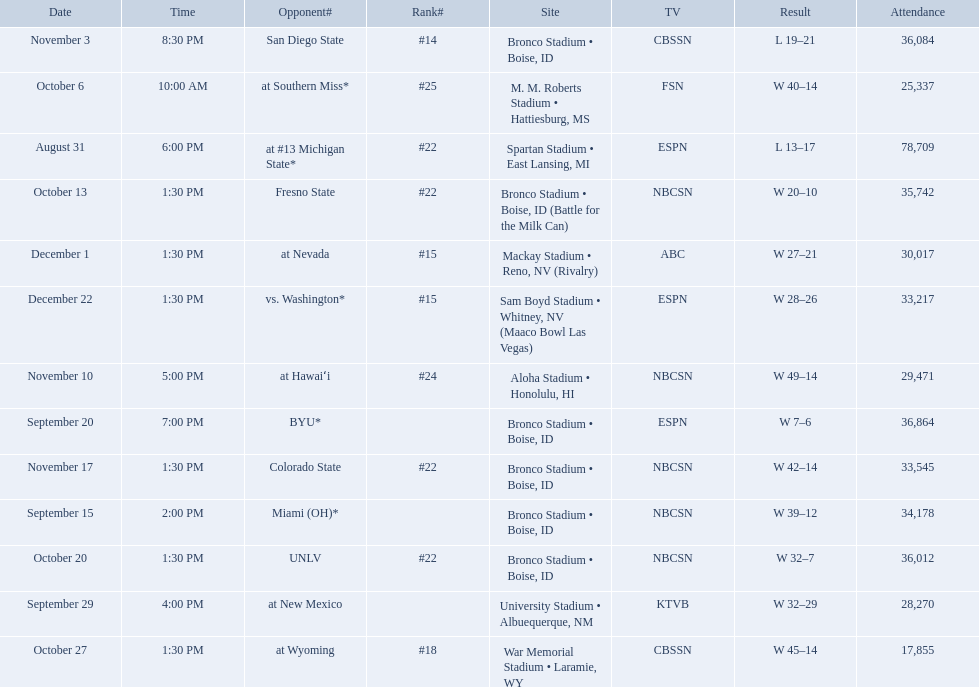What are all of the rankings? #22, , , , #25, #22, #22, #18, #14, #24, #22, #15, #15. Which of them was the best position? #14. What was the team's listed rankings for the season? #22, , , , #25, #22, #22, #18, #14, #24, #22, #15, #15. Which of these ranks is the best? #14. 